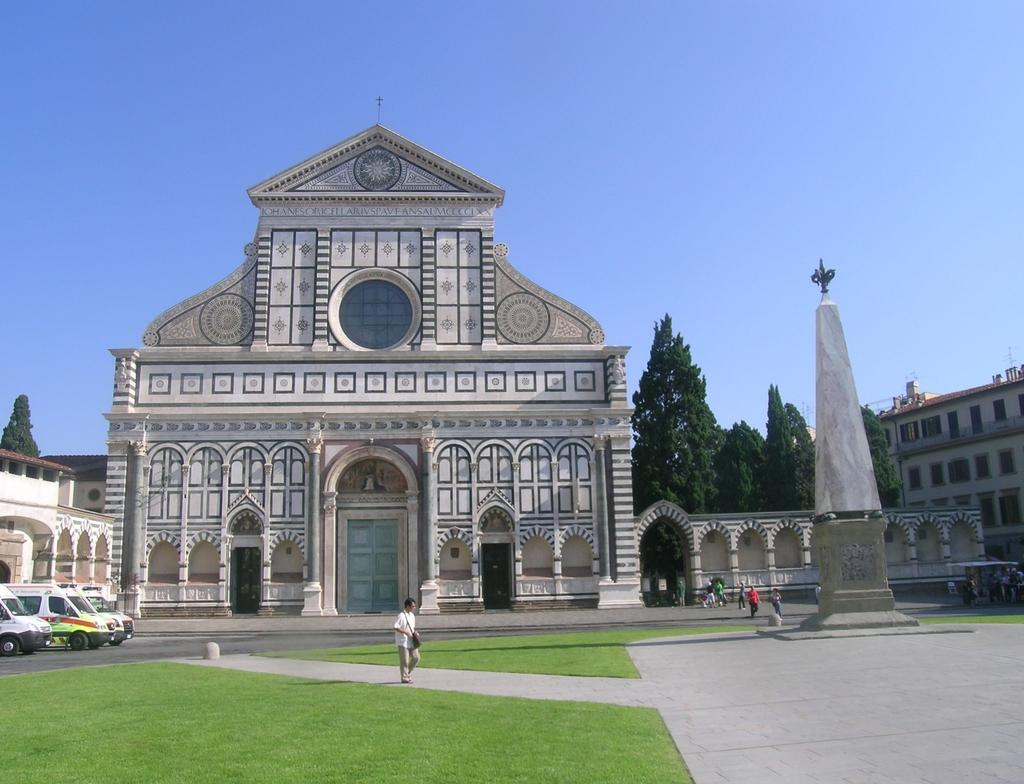What structure is the main subject of the image? There is a building in the image. What can be seen in front of the building? There are people in front of the building. What is located in the left corner of the image? There are vehicles in the left corner of the image. What is present in the right corner of the image? There are trees and an obelisk in the right corner of the image. What type of wound can be seen on the obelisk in the image? There is no wound present on the obelisk in the image. How many stitches are required to repair the damage to the trees in the image? There is no damage or need for stitches on the trees in the image. 